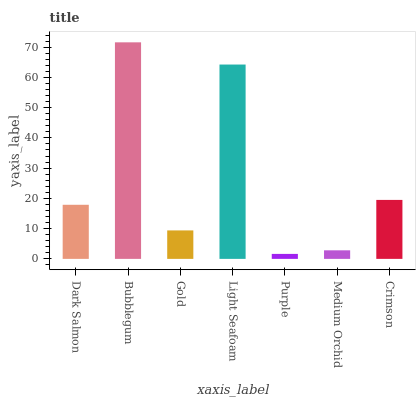Is Purple the minimum?
Answer yes or no. Yes. Is Bubblegum the maximum?
Answer yes or no. Yes. Is Gold the minimum?
Answer yes or no. No. Is Gold the maximum?
Answer yes or no. No. Is Bubblegum greater than Gold?
Answer yes or no. Yes. Is Gold less than Bubblegum?
Answer yes or no. Yes. Is Gold greater than Bubblegum?
Answer yes or no. No. Is Bubblegum less than Gold?
Answer yes or no. No. Is Dark Salmon the high median?
Answer yes or no. Yes. Is Dark Salmon the low median?
Answer yes or no. Yes. Is Medium Orchid the high median?
Answer yes or no. No. Is Purple the low median?
Answer yes or no. No. 